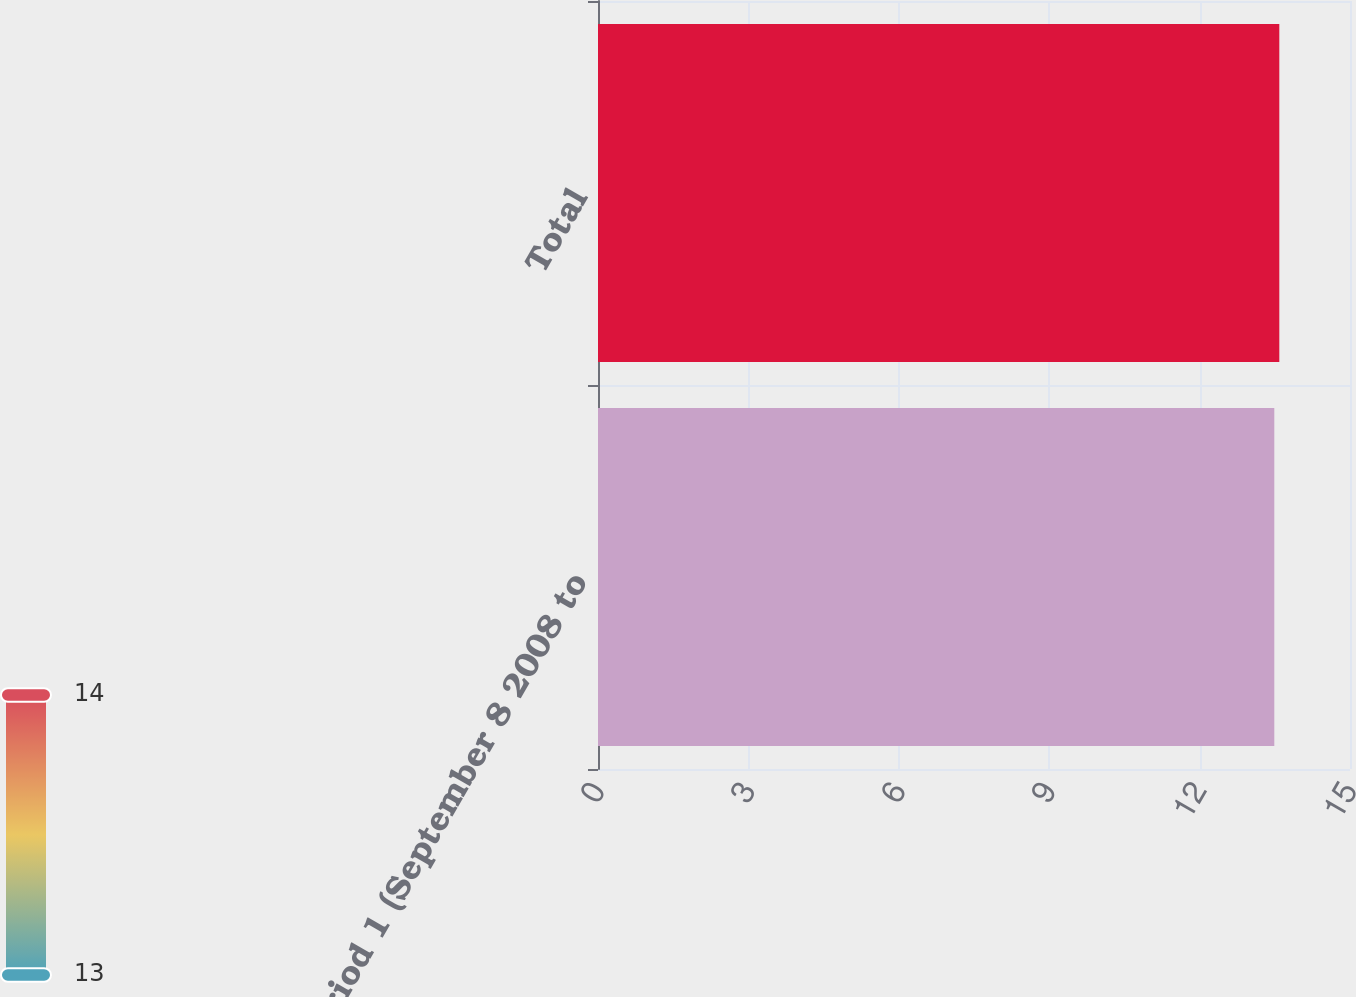Convert chart to OTSL. <chart><loc_0><loc_0><loc_500><loc_500><bar_chart><fcel>Period 1 (September 8 2008 to<fcel>Total<nl><fcel>13.49<fcel>13.59<nl></chart> 